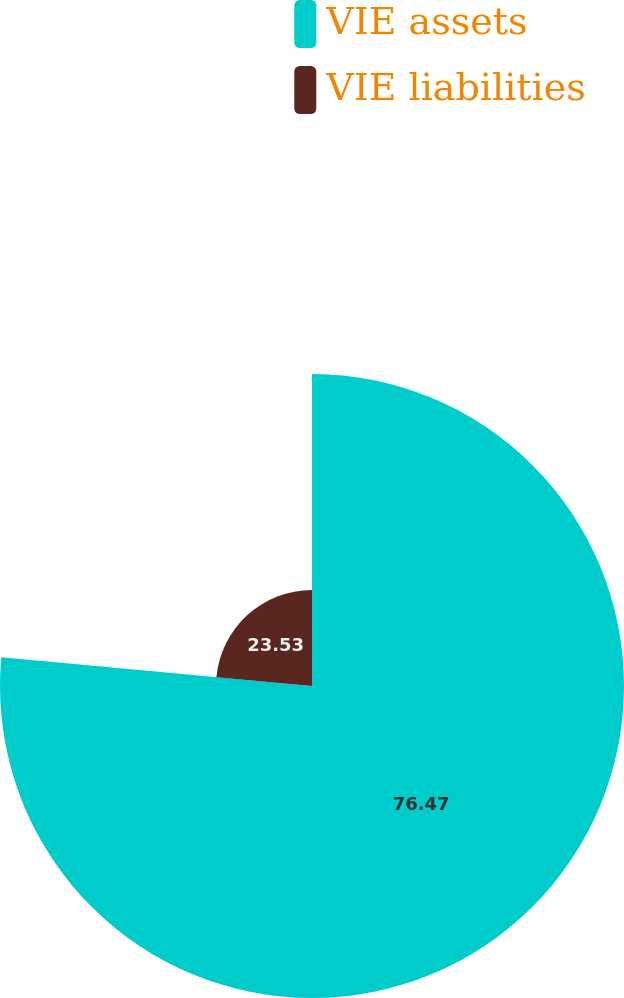Convert chart. <chart><loc_0><loc_0><loc_500><loc_500><pie_chart><fcel>VIE assets<fcel>VIE liabilities<nl><fcel>76.47%<fcel>23.53%<nl></chart> 